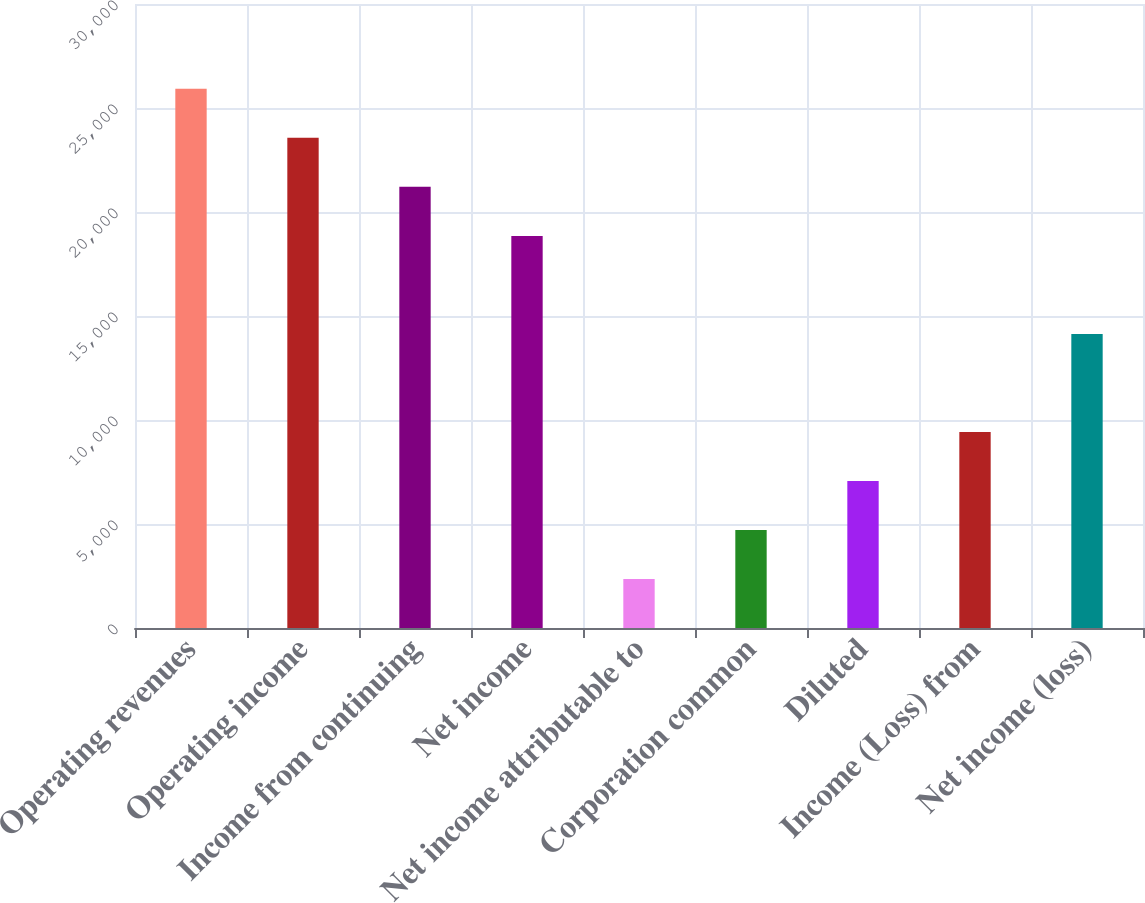Convert chart. <chart><loc_0><loc_0><loc_500><loc_500><bar_chart><fcel>Operating revenues<fcel>Operating income<fcel>Income from continuing<fcel>Net income<fcel>Net income attributable to<fcel>Corporation common<fcel>Diluted<fcel>Income (Loss) from<fcel>Net income (loss)<nl><fcel>25921.4<fcel>23565<fcel>21208.6<fcel>18852.1<fcel>2357.04<fcel>4713.48<fcel>7069.92<fcel>9426.36<fcel>14139.2<nl></chart> 